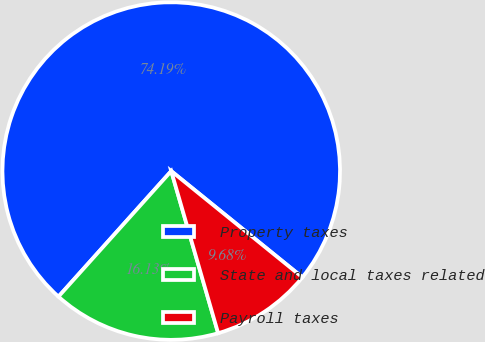Convert chart to OTSL. <chart><loc_0><loc_0><loc_500><loc_500><pie_chart><fcel>Property taxes<fcel>State and local taxes related<fcel>Payroll taxes<nl><fcel>74.19%<fcel>16.13%<fcel>9.68%<nl></chart> 